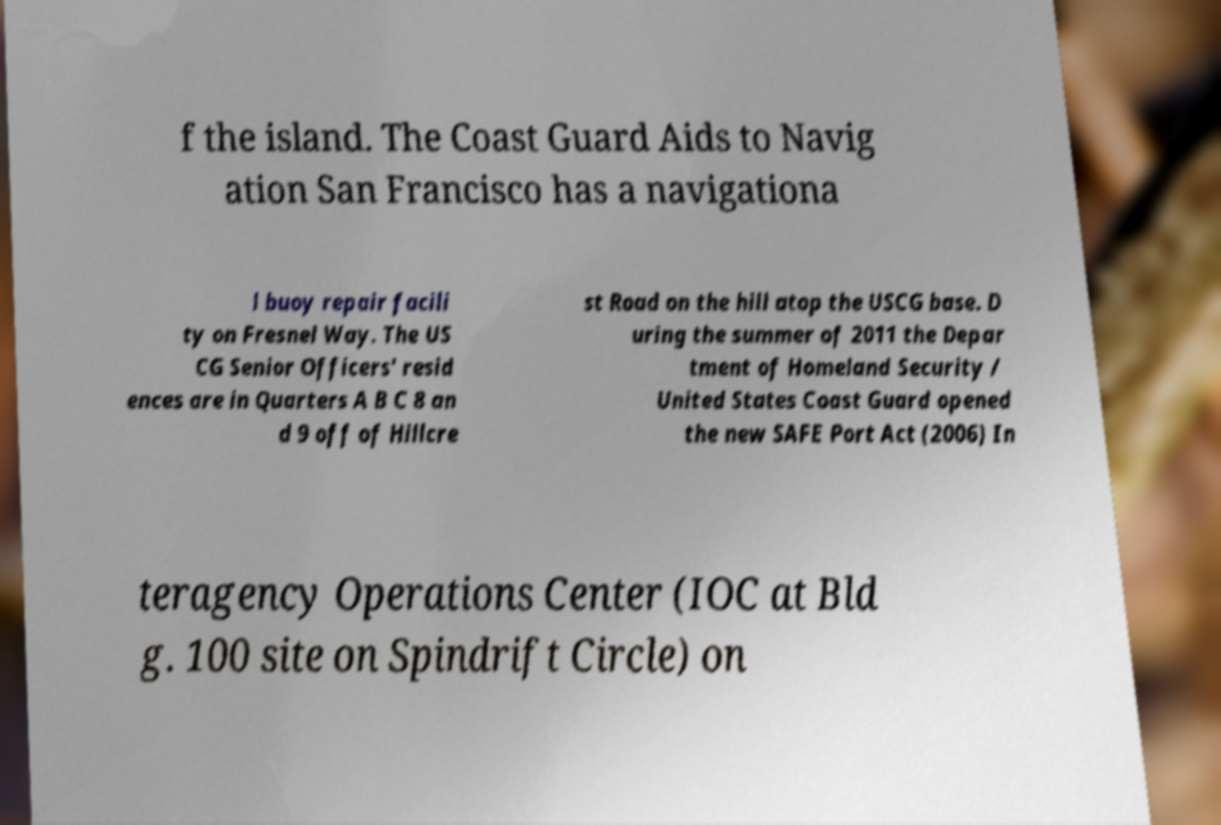Please read and relay the text visible in this image. What does it say? f the island. The Coast Guard Aids to Navig ation San Francisco has a navigationa l buoy repair facili ty on Fresnel Way. The US CG Senior Officers' resid ences are in Quarters A B C 8 an d 9 off of Hillcre st Road on the hill atop the USCG base. D uring the summer of 2011 the Depar tment of Homeland Security / United States Coast Guard opened the new SAFE Port Act (2006) In teragency Operations Center (IOC at Bld g. 100 site on Spindrift Circle) on 